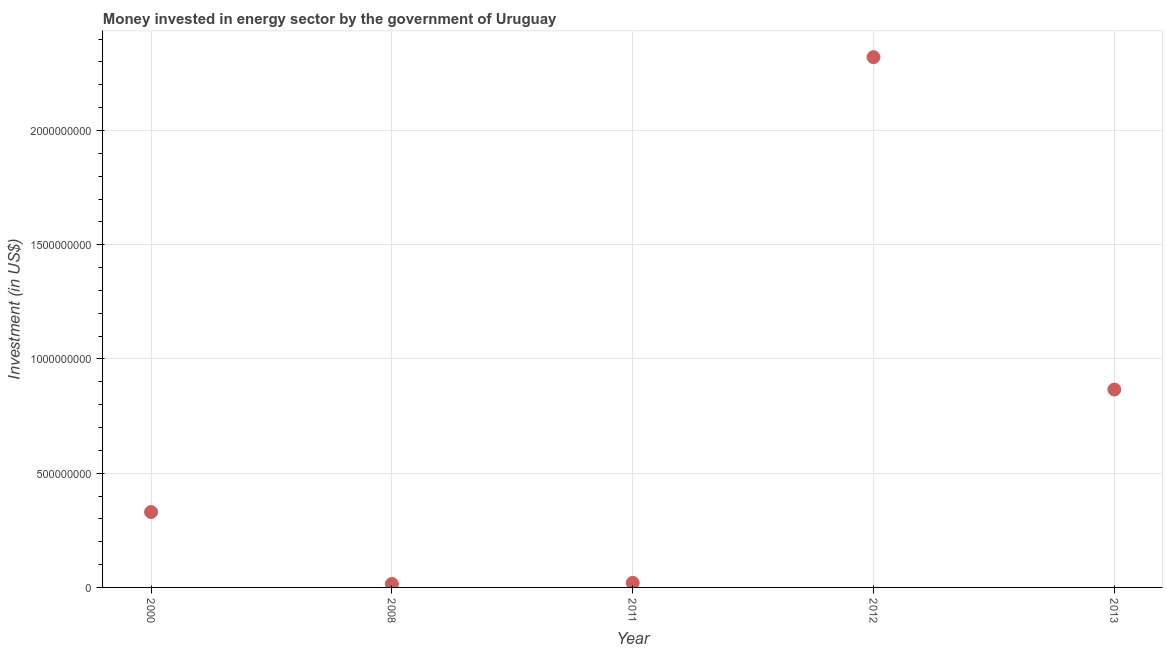What is the investment in energy in 2012?
Ensure brevity in your answer.  2.32e+09. Across all years, what is the maximum investment in energy?
Give a very brief answer. 2.32e+09. Across all years, what is the minimum investment in energy?
Provide a short and direct response. 1.50e+07. What is the sum of the investment in energy?
Your answer should be very brief. 3.55e+09. What is the difference between the investment in energy in 2008 and 2012?
Your answer should be compact. -2.31e+09. What is the average investment in energy per year?
Keep it short and to the point. 7.10e+08. What is the median investment in energy?
Your response must be concise. 3.30e+08. Do a majority of the years between 2013 and 2011 (inclusive) have investment in energy greater than 500000000 US$?
Provide a short and direct response. No. Is the difference between the investment in energy in 2012 and 2013 greater than the difference between any two years?
Your answer should be compact. No. What is the difference between the highest and the second highest investment in energy?
Your answer should be very brief. 1.45e+09. What is the difference between the highest and the lowest investment in energy?
Provide a short and direct response. 2.31e+09. In how many years, is the investment in energy greater than the average investment in energy taken over all years?
Give a very brief answer. 2. Does the investment in energy monotonically increase over the years?
Your answer should be compact. No. How many dotlines are there?
Offer a terse response. 1. What is the difference between two consecutive major ticks on the Y-axis?
Offer a terse response. 5.00e+08. Does the graph contain any zero values?
Offer a terse response. No. Does the graph contain grids?
Your answer should be very brief. Yes. What is the title of the graph?
Provide a succinct answer. Money invested in energy sector by the government of Uruguay. What is the label or title of the Y-axis?
Offer a very short reply. Investment (in US$). What is the Investment (in US$) in 2000?
Provide a short and direct response. 3.30e+08. What is the Investment (in US$) in 2008?
Your answer should be very brief. 1.50e+07. What is the Investment (in US$) in 2012?
Offer a very short reply. 2.32e+09. What is the Investment (in US$) in 2013?
Your response must be concise. 8.66e+08. What is the difference between the Investment (in US$) in 2000 and 2008?
Ensure brevity in your answer.  3.15e+08. What is the difference between the Investment (in US$) in 2000 and 2011?
Make the answer very short. 3.10e+08. What is the difference between the Investment (in US$) in 2000 and 2012?
Your answer should be compact. -1.99e+09. What is the difference between the Investment (in US$) in 2000 and 2013?
Give a very brief answer. -5.36e+08. What is the difference between the Investment (in US$) in 2008 and 2011?
Make the answer very short. -5.00e+06. What is the difference between the Investment (in US$) in 2008 and 2012?
Offer a terse response. -2.31e+09. What is the difference between the Investment (in US$) in 2008 and 2013?
Your response must be concise. -8.51e+08. What is the difference between the Investment (in US$) in 2011 and 2012?
Your answer should be compact. -2.30e+09. What is the difference between the Investment (in US$) in 2011 and 2013?
Give a very brief answer. -8.46e+08. What is the difference between the Investment (in US$) in 2012 and 2013?
Your answer should be very brief. 1.45e+09. What is the ratio of the Investment (in US$) in 2000 to that in 2012?
Make the answer very short. 0.14. What is the ratio of the Investment (in US$) in 2000 to that in 2013?
Your answer should be very brief. 0.38. What is the ratio of the Investment (in US$) in 2008 to that in 2011?
Provide a short and direct response. 0.75. What is the ratio of the Investment (in US$) in 2008 to that in 2012?
Make the answer very short. 0.01. What is the ratio of the Investment (in US$) in 2008 to that in 2013?
Make the answer very short. 0.02. What is the ratio of the Investment (in US$) in 2011 to that in 2012?
Give a very brief answer. 0.01. What is the ratio of the Investment (in US$) in 2011 to that in 2013?
Offer a terse response. 0.02. What is the ratio of the Investment (in US$) in 2012 to that in 2013?
Provide a short and direct response. 2.68. 